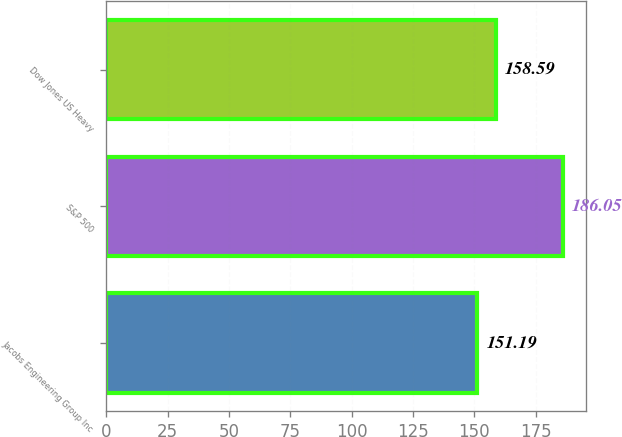Convert chart to OTSL. <chart><loc_0><loc_0><loc_500><loc_500><bar_chart><fcel>Jacobs Engineering Group Inc<fcel>S&P 500<fcel>Dow Jones US Heavy<nl><fcel>151.19<fcel>186.05<fcel>158.59<nl></chart> 